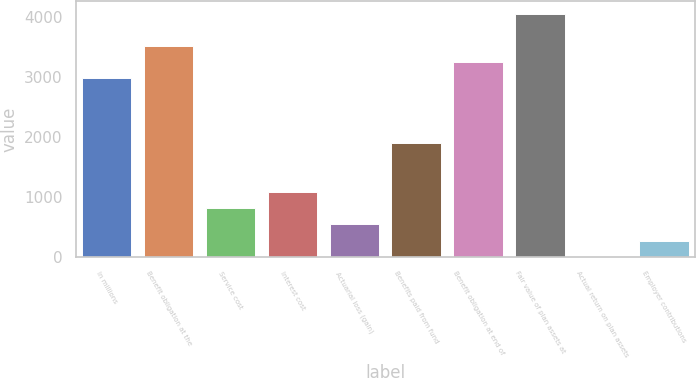Convert chart to OTSL. <chart><loc_0><loc_0><loc_500><loc_500><bar_chart><fcel>In millions<fcel>Benefit obligation at the<fcel>Service cost<fcel>Interest cost<fcel>Actuarial loss (gain)<fcel>Benefits paid from fund<fcel>Benefit obligation at end of<fcel>Fair value of plan assets at<fcel>Actual return on plan assets<fcel>Employer contributions<nl><fcel>2983.5<fcel>3524.5<fcel>819.5<fcel>1090<fcel>549<fcel>1901.5<fcel>3254<fcel>4065.5<fcel>8<fcel>278.5<nl></chart> 